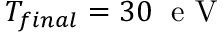Convert formula to latex. <formula><loc_0><loc_0><loc_500><loc_500>T _ { f i n a l } = 3 0 \, e V</formula> 